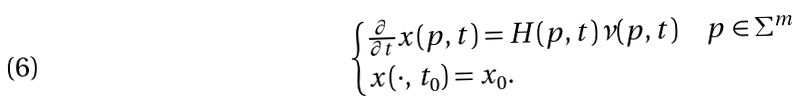<formula> <loc_0><loc_0><loc_500><loc_500>\begin{cases} \frac { \partial } { \partial t } x ( p , t ) = H ( p , t ) \nu ( p , t ) & p \in \Sigma ^ { m } \\ x ( \cdot , \, t _ { 0 } ) = x _ { 0 } . & \end{cases}</formula> 